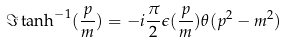Convert formula to latex. <formula><loc_0><loc_0><loc_500><loc_500>\Im \tanh ^ { - 1 } ( \frac { p } { m } ) = - i \frac { \pi } { 2 } \epsilon ( \frac { p } { m } ) \theta ( p ^ { 2 } - m ^ { 2 } )</formula> 